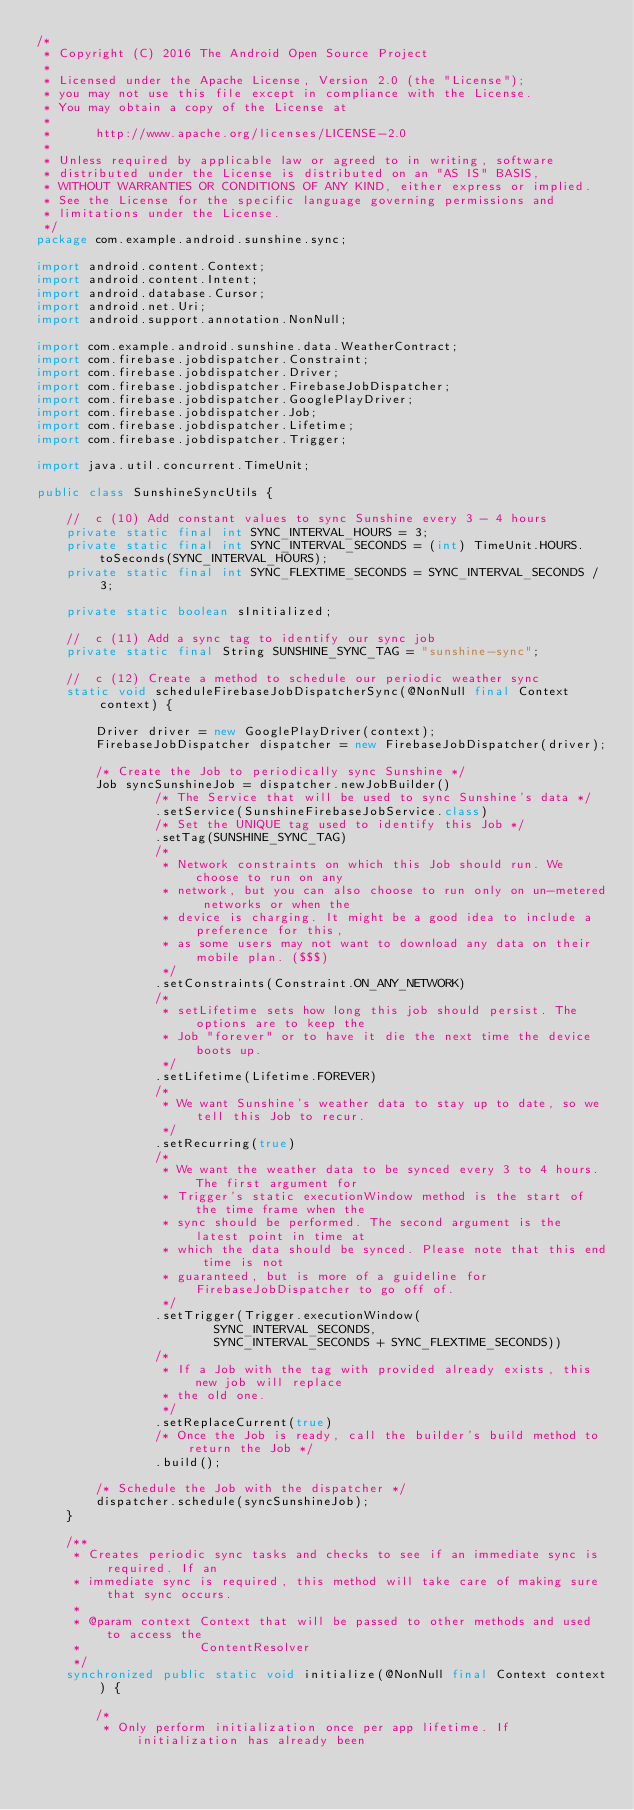Convert code to text. <code><loc_0><loc_0><loc_500><loc_500><_Java_>/*
 * Copyright (C) 2016 The Android Open Source Project
 *
 * Licensed under the Apache License, Version 2.0 (the "License");
 * you may not use this file except in compliance with the License.
 * You may obtain a copy of the License at
 *
 *      http://www.apache.org/licenses/LICENSE-2.0
 *
 * Unless required by applicable law or agreed to in writing, software
 * distributed under the License is distributed on an "AS IS" BASIS,
 * WITHOUT WARRANTIES OR CONDITIONS OF ANY KIND, either express or implied.
 * See the License for the specific language governing permissions and
 * limitations under the License.
 */
package com.example.android.sunshine.sync;

import android.content.Context;
import android.content.Intent;
import android.database.Cursor;
import android.net.Uri;
import android.support.annotation.NonNull;

import com.example.android.sunshine.data.WeatherContract;
import com.firebase.jobdispatcher.Constraint;
import com.firebase.jobdispatcher.Driver;
import com.firebase.jobdispatcher.FirebaseJobDispatcher;
import com.firebase.jobdispatcher.GooglePlayDriver;
import com.firebase.jobdispatcher.Job;
import com.firebase.jobdispatcher.Lifetime;
import com.firebase.jobdispatcher.Trigger;

import java.util.concurrent.TimeUnit;

public class SunshineSyncUtils {

    //  c (10) Add constant values to sync Sunshine every 3 - 4 hours
    private static final int SYNC_INTERVAL_HOURS = 3;
    private static final int SYNC_INTERVAL_SECONDS = (int) TimeUnit.HOURS.toSeconds(SYNC_INTERVAL_HOURS);
    private static final int SYNC_FLEXTIME_SECONDS = SYNC_INTERVAL_SECONDS / 3;

    private static boolean sInitialized;

    //  c (11) Add a sync tag to identify our sync job
    private static final String SUNSHINE_SYNC_TAG = "sunshine-sync";

    //  c (12) Create a method to schedule our periodic weather sync
    static void scheduleFirebaseJobDispatcherSync(@NonNull final Context context) {

        Driver driver = new GooglePlayDriver(context);
        FirebaseJobDispatcher dispatcher = new FirebaseJobDispatcher(driver);

        /* Create the Job to periodically sync Sunshine */
        Job syncSunshineJob = dispatcher.newJobBuilder()
                /* The Service that will be used to sync Sunshine's data */
                .setService(SunshineFirebaseJobService.class)
                /* Set the UNIQUE tag used to identify this Job */
                .setTag(SUNSHINE_SYNC_TAG)
                /*
                 * Network constraints on which this Job should run. We choose to run on any
                 * network, but you can also choose to run only on un-metered networks or when the
                 * device is charging. It might be a good idea to include a preference for this,
                 * as some users may not want to download any data on their mobile plan. ($$$)
                 */
                .setConstraints(Constraint.ON_ANY_NETWORK)
                /*
                 * setLifetime sets how long this job should persist. The options are to keep the
                 * Job "forever" or to have it die the next time the device boots up.
                 */
                .setLifetime(Lifetime.FOREVER)
                /*
                 * We want Sunshine's weather data to stay up to date, so we tell this Job to recur.
                 */
                .setRecurring(true)
                /*
                 * We want the weather data to be synced every 3 to 4 hours. The first argument for
                 * Trigger's static executionWindow method is the start of the time frame when the
                 * sync should be performed. The second argument is the latest point in time at
                 * which the data should be synced. Please note that this end time is not
                 * guaranteed, but is more of a guideline for FirebaseJobDispatcher to go off of.
                 */
                .setTrigger(Trigger.executionWindow(
                        SYNC_INTERVAL_SECONDS,
                        SYNC_INTERVAL_SECONDS + SYNC_FLEXTIME_SECONDS))
                /*
                 * If a Job with the tag with provided already exists, this new job will replace
                 * the old one.
                 */
                .setReplaceCurrent(true)
                /* Once the Job is ready, call the builder's build method to return the Job */
                .build();

        /* Schedule the Job with the dispatcher */
        dispatcher.schedule(syncSunshineJob);
    }

    /**
     * Creates periodic sync tasks and checks to see if an immediate sync is required. If an
     * immediate sync is required, this method will take care of making sure that sync occurs.
     *
     * @param context Context that will be passed to other methods and used to access the
     *                ContentResolver
     */
    synchronized public static void initialize(@NonNull final Context context) {

        /*
         * Only perform initialization once per app lifetime. If initialization has already been</code> 